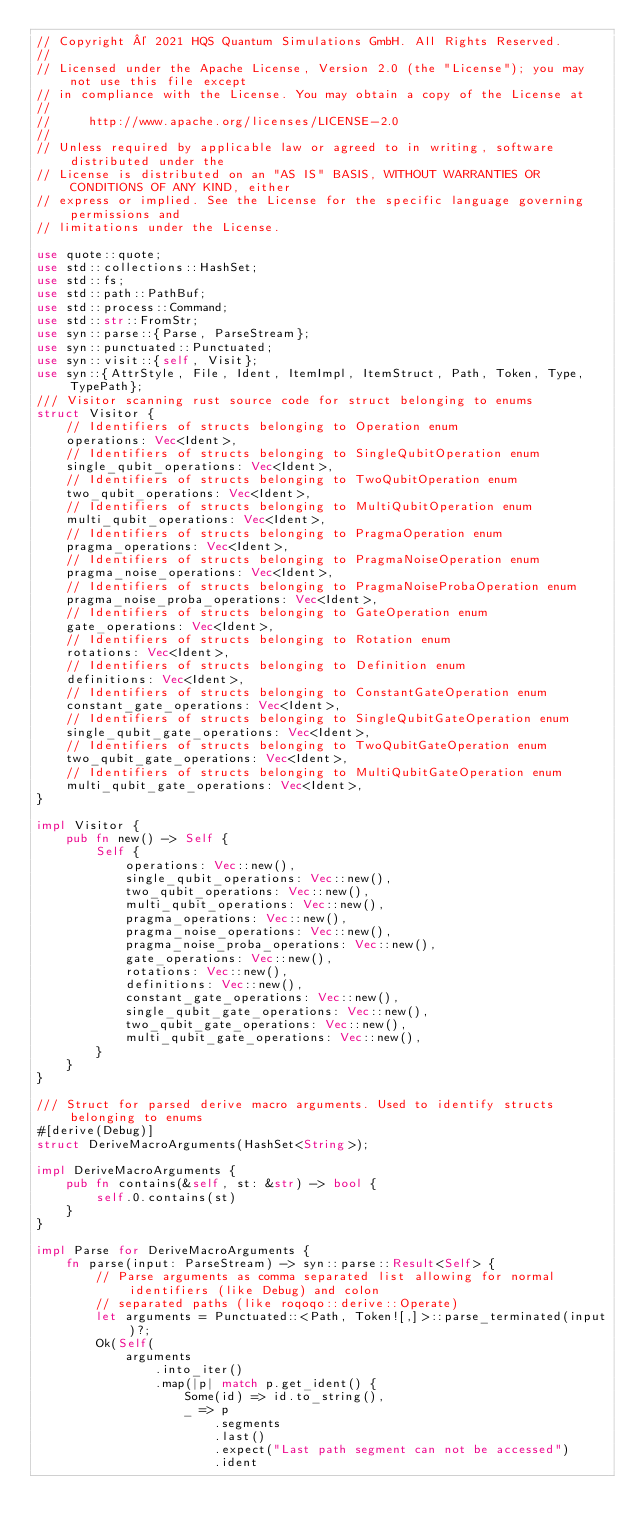Convert code to text. <code><loc_0><loc_0><loc_500><loc_500><_Rust_>// Copyright © 2021 HQS Quantum Simulations GmbH. All Rights Reserved.
//
// Licensed under the Apache License, Version 2.0 (the "License"); you may not use this file except
// in compliance with the License. You may obtain a copy of the License at
//
//     http://www.apache.org/licenses/LICENSE-2.0
//
// Unless required by applicable law or agreed to in writing, software distributed under the
// License is distributed on an "AS IS" BASIS, WITHOUT WARRANTIES OR CONDITIONS OF ANY KIND, either
// express or implied. See the License for the specific language governing permissions and
// limitations under the License.

use quote::quote;
use std::collections::HashSet;
use std::fs;
use std::path::PathBuf;
use std::process::Command;
use std::str::FromStr;
use syn::parse::{Parse, ParseStream};
use syn::punctuated::Punctuated;
use syn::visit::{self, Visit};
use syn::{AttrStyle, File, Ident, ItemImpl, ItemStruct, Path, Token, Type, TypePath};
/// Visitor scanning rust source code for struct belonging to enums
struct Visitor {
    // Identifiers of structs belonging to Operation enum
    operations: Vec<Ident>,
    // Identifiers of structs belonging to SingleQubitOperation enum
    single_qubit_operations: Vec<Ident>,
    // Identifiers of structs belonging to TwoQubitOperation enum
    two_qubit_operations: Vec<Ident>,
    // Identifiers of structs belonging to MultiQubitOperation enum
    multi_qubit_operations: Vec<Ident>,
    // Identifiers of structs belonging to PragmaOperation enum
    pragma_operations: Vec<Ident>,
    // Identifiers of structs belonging to PragmaNoiseOperation enum
    pragma_noise_operations: Vec<Ident>,
    // Identifiers of structs belonging to PragmaNoiseProbaOperation enum
    pragma_noise_proba_operations: Vec<Ident>,
    // Identifiers of structs belonging to GateOperation enum
    gate_operations: Vec<Ident>,
    // Identifiers of structs belonging to Rotation enum
    rotations: Vec<Ident>,
    // Identifiers of structs belonging to Definition enum
    definitions: Vec<Ident>,
    // Identifiers of structs belonging to ConstantGateOperation enum
    constant_gate_operations: Vec<Ident>,
    // Identifiers of structs belonging to SingleQubitGateOperation enum
    single_qubit_gate_operations: Vec<Ident>,
    // Identifiers of structs belonging to TwoQubitGateOperation enum
    two_qubit_gate_operations: Vec<Ident>,
    // Identifiers of structs belonging to MultiQubitGateOperation enum
    multi_qubit_gate_operations: Vec<Ident>,
}

impl Visitor {
    pub fn new() -> Self {
        Self {
            operations: Vec::new(),
            single_qubit_operations: Vec::new(),
            two_qubit_operations: Vec::new(),
            multi_qubit_operations: Vec::new(),
            pragma_operations: Vec::new(),
            pragma_noise_operations: Vec::new(),
            pragma_noise_proba_operations: Vec::new(),
            gate_operations: Vec::new(),
            rotations: Vec::new(),
            definitions: Vec::new(),
            constant_gate_operations: Vec::new(),
            single_qubit_gate_operations: Vec::new(),
            two_qubit_gate_operations: Vec::new(),
            multi_qubit_gate_operations: Vec::new(),
        }
    }
}

/// Struct for parsed derive macro arguments. Used to identify structs belonging to enums
#[derive(Debug)]
struct DeriveMacroArguments(HashSet<String>);

impl DeriveMacroArguments {
    pub fn contains(&self, st: &str) -> bool {
        self.0.contains(st)
    }
}

impl Parse for DeriveMacroArguments {
    fn parse(input: ParseStream) -> syn::parse::Result<Self> {
        // Parse arguments as comma separated list allowing for normal identifiers (like Debug) and colon
        // separated paths (like roqoqo::derive::Operate)
        let arguments = Punctuated::<Path, Token![,]>::parse_terminated(input)?;
        Ok(Self(
            arguments
                .into_iter()
                .map(|p| match p.get_ident() {
                    Some(id) => id.to_string(),
                    _ => p
                        .segments
                        .last()
                        .expect("Last path segment can not be accessed")
                        .ident</code> 